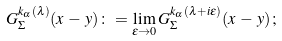Convert formula to latex. <formula><loc_0><loc_0><loc_500><loc_500>G ^ { k _ { \alpha } ( \lambda ) } _ { \Sigma } ( x \, - \, y ) \colon = \lim _ { \varepsilon \to 0 } G ^ { k _ { \alpha } ( \lambda + i \varepsilon ) } _ { \Sigma } ( x \, - \, y ) \, ;</formula> 